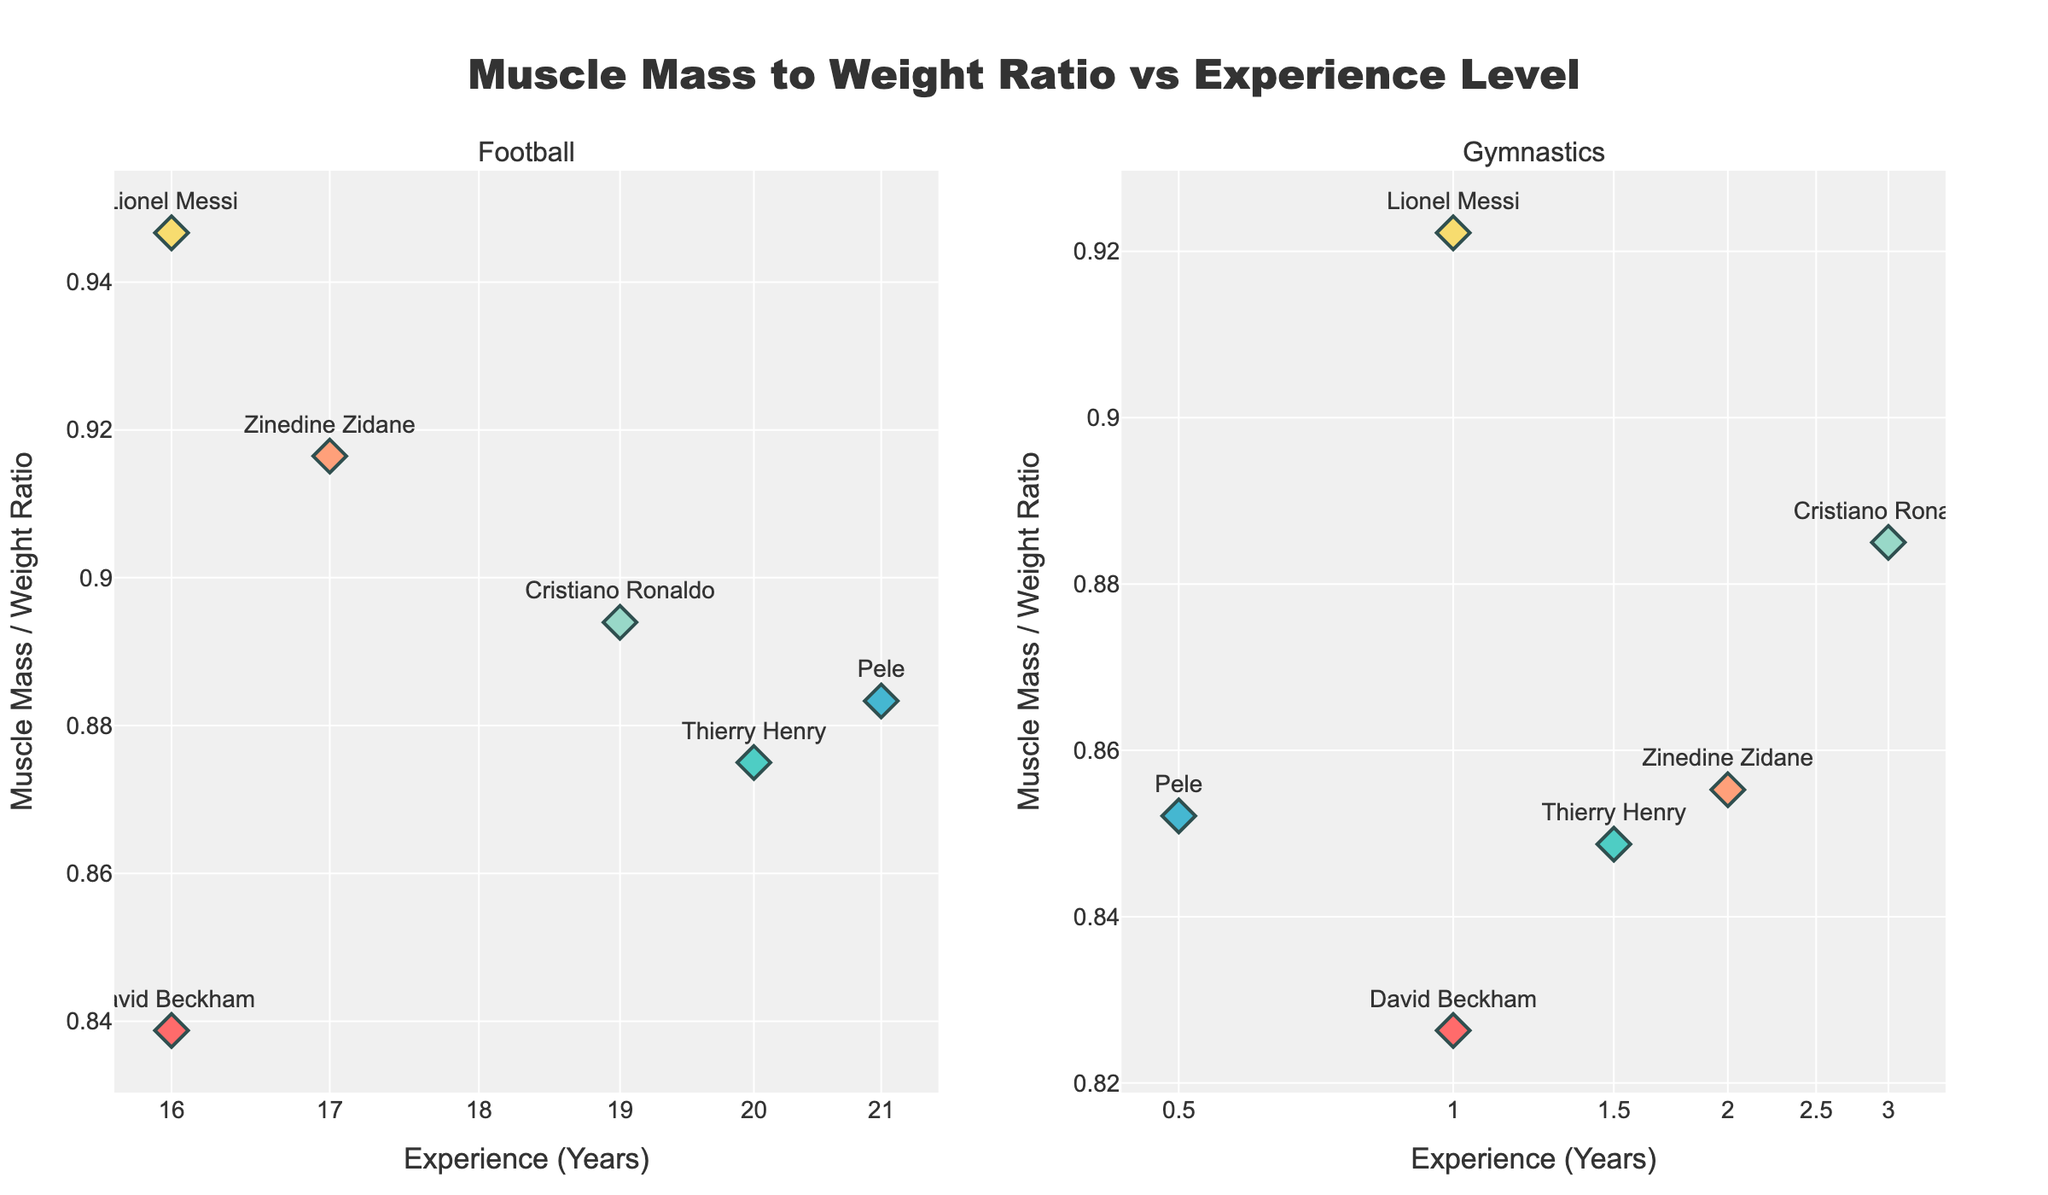What is the title of the figure? The title is positioned at the top center of the figure.
Answer: Muscle Mass to Weight Ratio vs Experience Level What is the x-axis of the left subplot? The x-axis label on the left subplot shows "Experience (Years)" with log scale.
Answer: Experience (Years) (log scale) How many data points are there for football players? Count the markers in the left subplot.
Answer: 6 What color represents Cristiano Ronaldo in both subplots? Identify the unique color for Cristiano Ronaldo in both subplots.
Answer: Blue Who has the highest muscle mass to weight ratio among football players? Compare the y-axis values for football players.
Answer: Cristiano Ronaldo What is the muscle mass to weight ratio for Lionel Messi when he transitioned to gymnastics? Find Lionel Messi's marker and identify its y-axis value in the right subplot.
Answer: Approximately 0.92 What is the general trend of muscle mass to weight ratio as experience increases for football players? Observe the pattern of markers in the left subplot as the x-axis (Experience Years) increases.
Answer: Generally increasing Which football player shows the most significant change in muscle mass to weight ratio when transitioning to gymnastics? Compare the positions of markers between the left and right subplots for each player.
Answer: Cristiano Ronaldo How does the muscle mass to weight ratio of Zinedine Zidane in gymnastics compare to his ratio in football? Find Zinedine Zidane’s markers in both subplots and compare their y-axis positions.
Answer: Ratio in gymnastics is slightly lower than in football What is the x-axis range in the gymnastics subplot? Observe the range of the x-axis values in the right subplot.
Answer: 0.5 to 3 years 